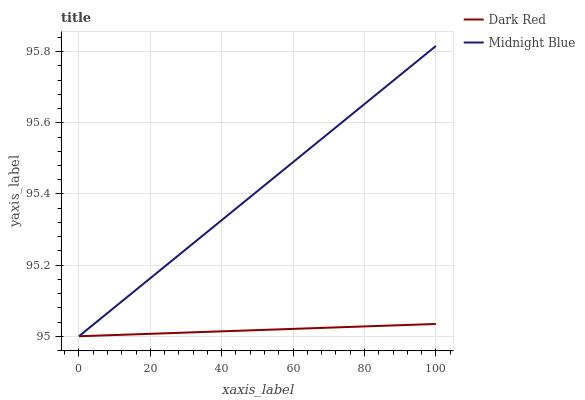Does Midnight Blue have the minimum area under the curve?
Answer yes or no. No. Is Midnight Blue the smoothest?
Answer yes or no. No. 